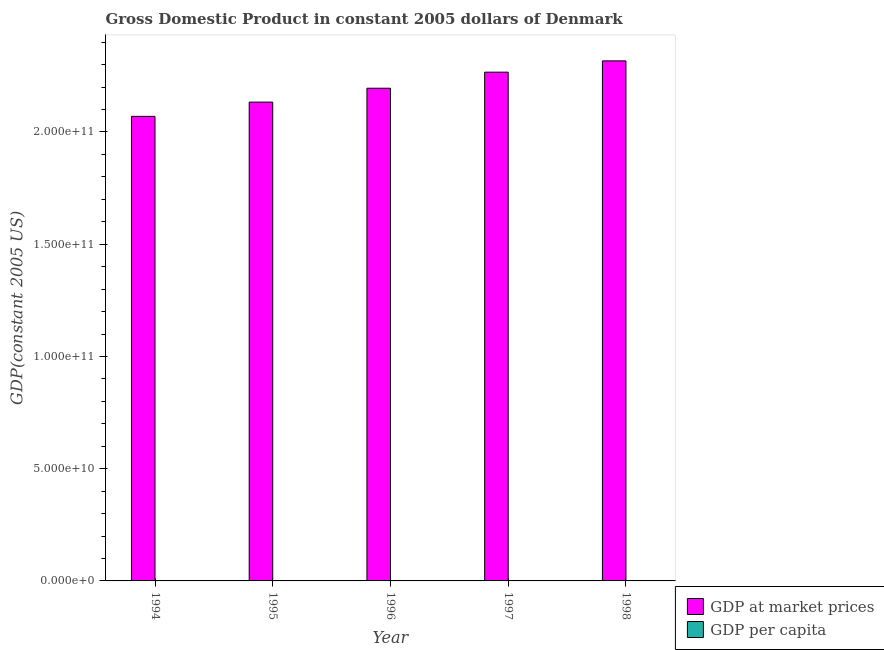How many different coloured bars are there?
Keep it short and to the point. 2. How many groups of bars are there?
Your answer should be compact. 5. How many bars are there on the 3rd tick from the left?
Offer a very short reply. 2. How many bars are there on the 3rd tick from the right?
Make the answer very short. 2. In how many cases, is the number of bars for a given year not equal to the number of legend labels?
Offer a very short reply. 0. What is the gdp per capita in 1997?
Your response must be concise. 4.29e+04. Across all years, what is the maximum gdp at market prices?
Provide a short and direct response. 2.32e+11. Across all years, what is the minimum gdp at market prices?
Offer a very short reply. 2.07e+11. In which year was the gdp per capita maximum?
Offer a terse response. 1998. What is the total gdp per capita in the graph?
Keep it short and to the point. 2.09e+05. What is the difference between the gdp per capita in 1996 and that in 1997?
Keep it short and to the point. -1181.36. What is the difference between the gdp at market prices in 1996 and the gdp per capita in 1998?
Your answer should be compact. -1.22e+1. What is the average gdp per capita per year?
Your answer should be very brief. 4.18e+04. What is the ratio of the gdp at market prices in 1994 to that in 1995?
Keep it short and to the point. 0.97. Is the gdp per capita in 1996 less than that in 1998?
Offer a terse response. Yes. Is the difference between the gdp at market prices in 1994 and 1997 greater than the difference between the gdp per capita in 1994 and 1997?
Ensure brevity in your answer.  No. What is the difference between the highest and the second highest gdp at market prices?
Your response must be concise. 5.03e+09. What is the difference between the highest and the lowest gdp at market prices?
Provide a succinct answer. 2.47e+1. What does the 1st bar from the left in 1998 represents?
Keep it short and to the point. GDP at market prices. What does the 2nd bar from the right in 1996 represents?
Your answer should be compact. GDP at market prices. Are all the bars in the graph horizontal?
Provide a short and direct response. No. How many years are there in the graph?
Your answer should be compact. 5. What is the difference between two consecutive major ticks on the Y-axis?
Keep it short and to the point. 5.00e+1. Are the values on the major ticks of Y-axis written in scientific E-notation?
Your response must be concise. Yes. Does the graph contain any zero values?
Make the answer very short. No. Where does the legend appear in the graph?
Your response must be concise. Bottom right. What is the title of the graph?
Provide a short and direct response. Gross Domestic Product in constant 2005 dollars of Denmark. What is the label or title of the X-axis?
Ensure brevity in your answer.  Year. What is the label or title of the Y-axis?
Provide a short and direct response. GDP(constant 2005 US). What is the GDP(constant 2005 US) of GDP at market prices in 1994?
Ensure brevity in your answer.  2.07e+11. What is the GDP(constant 2005 US) in GDP per capita in 1994?
Make the answer very short. 3.98e+04. What is the GDP(constant 2005 US) in GDP at market prices in 1995?
Keep it short and to the point. 2.13e+11. What is the GDP(constant 2005 US) of GDP per capita in 1995?
Your answer should be compact. 4.08e+04. What is the GDP(constant 2005 US) in GDP at market prices in 1996?
Make the answer very short. 2.19e+11. What is the GDP(constant 2005 US) of GDP per capita in 1996?
Your answer should be compact. 4.17e+04. What is the GDP(constant 2005 US) of GDP at market prices in 1997?
Keep it short and to the point. 2.27e+11. What is the GDP(constant 2005 US) of GDP per capita in 1997?
Offer a terse response. 4.29e+04. What is the GDP(constant 2005 US) in GDP at market prices in 1998?
Your answer should be very brief. 2.32e+11. What is the GDP(constant 2005 US) of GDP per capita in 1998?
Offer a very short reply. 4.37e+04. Across all years, what is the maximum GDP(constant 2005 US) in GDP at market prices?
Offer a very short reply. 2.32e+11. Across all years, what is the maximum GDP(constant 2005 US) in GDP per capita?
Keep it short and to the point. 4.37e+04. Across all years, what is the minimum GDP(constant 2005 US) of GDP at market prices?
Offer a terse response. 2.07e+11. Across all years, what is the minimum GDP(constant 2005 US) in GDP per capita?
Keep it short and to the point. 3.98e+04. What is the total GDP(constant 2005 US) in GDP at market prices in the graph?
Provide a short and direct response. 1.10e+12. What is the total GDP(constant 2005 US) in GDP per capita in the graph?
Offer a very short reply. 2.09e+05. What is the difference between the GDP(constant 2005 US) of GDP at market prices in 1994 and that in 1995?
Your response must be concise. -6.34e+09. What is the difference between the GDP(constant 2005 US) in GDP per capita in 1994 and that in 1995?
Offer a very short reply. -1005.63. What is the difference between the GDP(constant 2005 US) in GDP at market prices in 1994 and that in 1996?
Give a very brief answer. -1.25e+1. What is the difference between the GDP(constant 2005 US) of GDP per capita in 1994 and that in 1996?
Provide a short and direct response. -1951.02. What is the difference between the GDP(constant 2005 US) of GDP at market prices in 1994 and that in 1997?
Provide a short and direct response. -1.97e+1. What is the difference between the GDP(constant 2005 US) of GDP per capita in 1994 and that in 1997?
Your response must be concise. -3132.38. What is the difference between the GDP(constant 2005 US) of GDP at market prices in 1994 and that in 1998?
Keep it short and to the point. -2.47e+1. What is the difference between the GDP(constant 2005 US) of GDP per capita in 1994 and that in 1998?
Make the answer very short. -3924.74. What is the difference between the GDP(constant 2005 US) of GDP at market prices in 1995 and that in 1996?
Your response must be concise. -6.19e+09. What is the difference between the GDP(constant 2005 US) of GDP per capita in 1995 and that in 1996?
Provide a short and direct response. -945.39. What is the difference between the GDP(constant 2005 US) of GDP at market prices in 1995 and that in 1997?
Offer a very short reply. -1.33e+1. What is the difference between the GDP(constant 2005 US) in GDP per capita in 1995 and that in 1997?
Keep it short and to the point. -2126.75. What is the difference between the GDP(constant 2005 US) in GDP at market prices in 1995 and that in 1998?
Provide a succinct answer. -1.84e+1. What is the difference between the GDP(constant 2005 US) of GDP per capita in 1995 and that in 1998?
Provide a succinct answer. -2919.11. What is the difference between the GDP(constant 2005 US) of GDP at market prices in 1996 and that in 1997?
Provide a succinct answer. -7.16e+09. What is the difference between the GDP(constant 2005 US) of GDP per capita in 1996 and that in 1997?
Offer a terse response. -1181.36. What is the difference between the GDP(constant 2005 US) of GDP at market prices in 1996 and that in 1998?
Offer a very short reply. -1.22e+1. What is the difference between the GDP(constant 2005 US) in GDP per capita in 1996 and that in 1998?
Your answer should be compact. -1973.72. What is the difference between the GDP(constant 2005 US) in GDP at market prices in 1997 and that in 1998?
Your response must be concise. -5.03e+09. What is the difference between the GDP(constant 2005 US) in GDP per capita in 1997 and that in 1998?
Ensure brevity in your answer.  -792.36. What is the difference between the GDP(constant 2005 US) in GDP at market prices in 1994 and the GDP(constant 2005 US) in GDP per capita in 1995?
Your answer should be very brief. 2.07e+11. What is the difference between the GDP(constant 2005 US) of GDP at market prices in 1994 and the GDP(constant 2005 US) of GDP per capita in 1996?
Give a very brief answer. 2.07e+11. What is the difference between the GDP(constant 2005 US) in GDP at market prices in 1994 and the GDP(constant 2005 US) in GDP per capita in 1997?
Your answer should be compact. 2.07e+11. What is the difference between the GDP(constant 2005 US) in GDP at market prices in 1994 and the GDP(constant 2005 US) in GDP per capita in 1998?
Keep it short and to the point. 2.07e+11. What is the difference between the GDP(constant 2005 US) in GDP at market prices in 1995 and the GDP(constant 2005 US) in GDP per capita in 1996?
Provide a short and direct response. 2.13e+11. What is the difference between the GDP(constant 2005 US) in GDP at market prices in 1995 and the GDP(constant 2005 US) in GDP per capita in 1997?
Your answer should be very brief. 2.13e+11. What is the difference between the GDP(constant 2005 US) of GDP at market prices in 1995 and the GDP(constant 2005 US) of GDP per capita in 1998?
Offer a terse response. 2.13e+11. What is the difference between the GDP(constant 2005 US) in GDP at market prices in 1996 and the GDP(constant 2005 US) in GDP per capita in 1997?
Your answer should be very brief. 2.19e+11. What is the difference between the GDP(constant 2005 US) in GDP at market prices in 1996 and the GDP(constant 2005 US) in GDP per capita in 1998?
Provide a succinct answer. 2.19e+11. What is the difference between the GDP(constant 2005 US) in GDP at market prices in 1997 and the GDP(constant 2005 US) in GDP per capita in 1998?
Your response must be concise. 2.27e+11. What is the average GDP(constant 2005 US) of GDP at market prices per year?
Keep it short and to the point. 2.20e+11. What is the average GDP(constant 2005 US) of GDP per capita per year?
Provide a succinct answer. 4.18e+04. In the year 1994, what is the difference between the GDP(constant 2005 US) of GDP at market prices and GDP(constant 2005 US) of GDP per capita?
Offer a very short reply. 2.07e+11. In the year 1995, what is the difference between the GDP(constant 2005 US) of GDP at market prices and GDP(constant 2005 US) of GDP per capita?
Ensure brevity in your answer.  2.13e+11. In the year 1996, what is the difference between the GDP(constant 2005 US) of GDP at market prices and GDP(constant 2005 US) of GDP per capita?
Give a very brief answer. 2.19e+11. In the year 1997, what is the difference between the GDP(constant 2005 US) of GDP at market prices and GDP(constant 2005 US) of GDP per capita?
Keep it short and to the point. 2.27e+11. In the year 1998, what is the difference between the GDP(constant 2005 US) in GDP at market prices and GDP(constant 2005 US) in GDP per capita?
Your answer should be very brief. 2.32e+11. What is the ratio of the GDP(constant 2005 US) of GDP at market prices in 1994 to that in 1995?
Keep it short and to the point. 0.97. What is the ratio of the GDP(constant 2005 US) of GDP per capita in 1994 to that in 1995?
Make the answer very short. 0.98. What is the ratio of the GDP(constant 2005 US) in GDP at market prices in 1994 to that in 1996?
Keep it short and to the point. 0.94. What is the ratio of the GDP(constant 2005 US) of GDP per capita in 1994 to that in 1996?
Your answer should be very brief. 0.95. What is the ratio of the GDP(constant 2005 US) of GDP at market prices in 1994 to that in 1997?
Ensure brevity in your answer.  0.91. What is the ratio of the GDP(constant 2005 US) in GDP per capita in 1994 to that in 1997?
Offer a terse response. 0.93. What is the ratio of the GDP(constant 2005 US) of GDP at market prices in 1994 to that in 1998?
Offer a very short reply. 0.89. What is the ratio of the GDP(constant 2005 US) in GDP per capita in 1994 to that in 1998?
Keep it short and to the point. 0.91. What is the ratio of the GDP(constant 2005 US) in GDP at market prices in 1995 to that in 1996?
Ensure brevity in your answer.  0.97. What is the ratio of the GDP(constant 2005 US) in GDP per capita in 1995 to that in 1996?
Offer a very short reply. 0.98. What is the ratio of the GDP(constant 2005 US) in GDP at market prices in 1995 to that in 1997?
Ensure brevity in your answer.  0.94. What is the ratio of the GDP(constant 2005 US) in GDP per capita in 1995 to that in 1997?
Give a very brief answer. 0.95. What is the ratio of the GDP(constant 2005 US) in GDP at market prices in 1995 to that in 1998?
Ensure brevity in your answer.  0.92. What is the ratio of the GDP(constant 2005 US) of GDP per capita in 1995 to that in 1998?
Offer a terse response. 0.93. What is the ratio of the GDP(constant 2005 US) in GDP at market prices in 1996 to that in 1997?
Your answer should be compact. 0.97. What is the ratio of the GDP(constant 2005 US) of GDP per capita in 1996 to that in 1997?
Offer a very short reply. 0.97. What is the ratio of the GDP(constant 2005 US) of GDP per capita in 1996 to that in 1998?
Offer a terse response. 0.95. What is the ratio of the GDP(constant 2005 US) in GDP at market prices in 1997 to that in 1998?
Your response must be concise. 0.98. What is the ratio of the GDP(constant 2005 US) of GDP per capita in 1997 to that in 1998?
Give a very brief answer. 0.98. What is the difference between the highest and the second highest GDP(constant 2005 US) of GDP at market prices?
Your response must be concise. 5.03e+09. What is the difference between the highest and the second highest GDP(constant 2005 US) in GDP per capita?
Your response must be concise. 792.36. What is the difference between the highest and the lowest GDP(constant 2005 US) of GDP at market prices?
Your answer should be very brief. 2.47e+1. What is the difference between the highest and the lowest GDP(constant 2005 US) in GDP per capita?
Your response must be concise. 3924.74. 